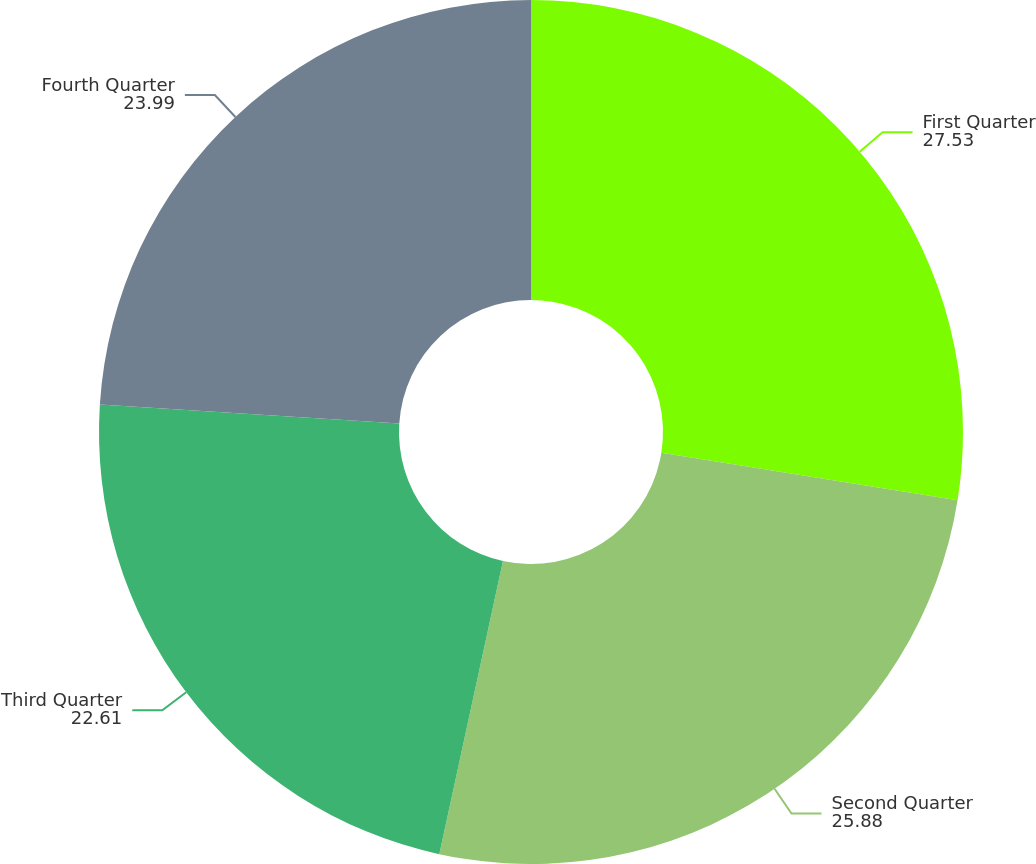Convert chart. <chart><loc_0><loc_0><loc_500><loc_500><pie_chart><fcel>First Quarter<fcel>Second Quarter<fcel>Third Quarter<fcel>Fourth Quarter<nl><fcel>27.53%<fcel>25.88%<fcel>22.61%<fcel>23.99%<nl></chart> 